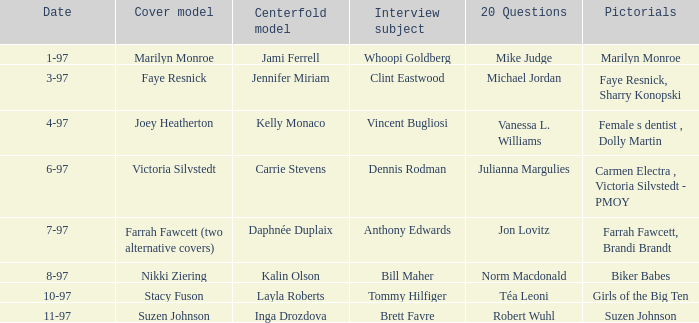When was Kalin Olson listed as  the centerfold model? 8-97. 